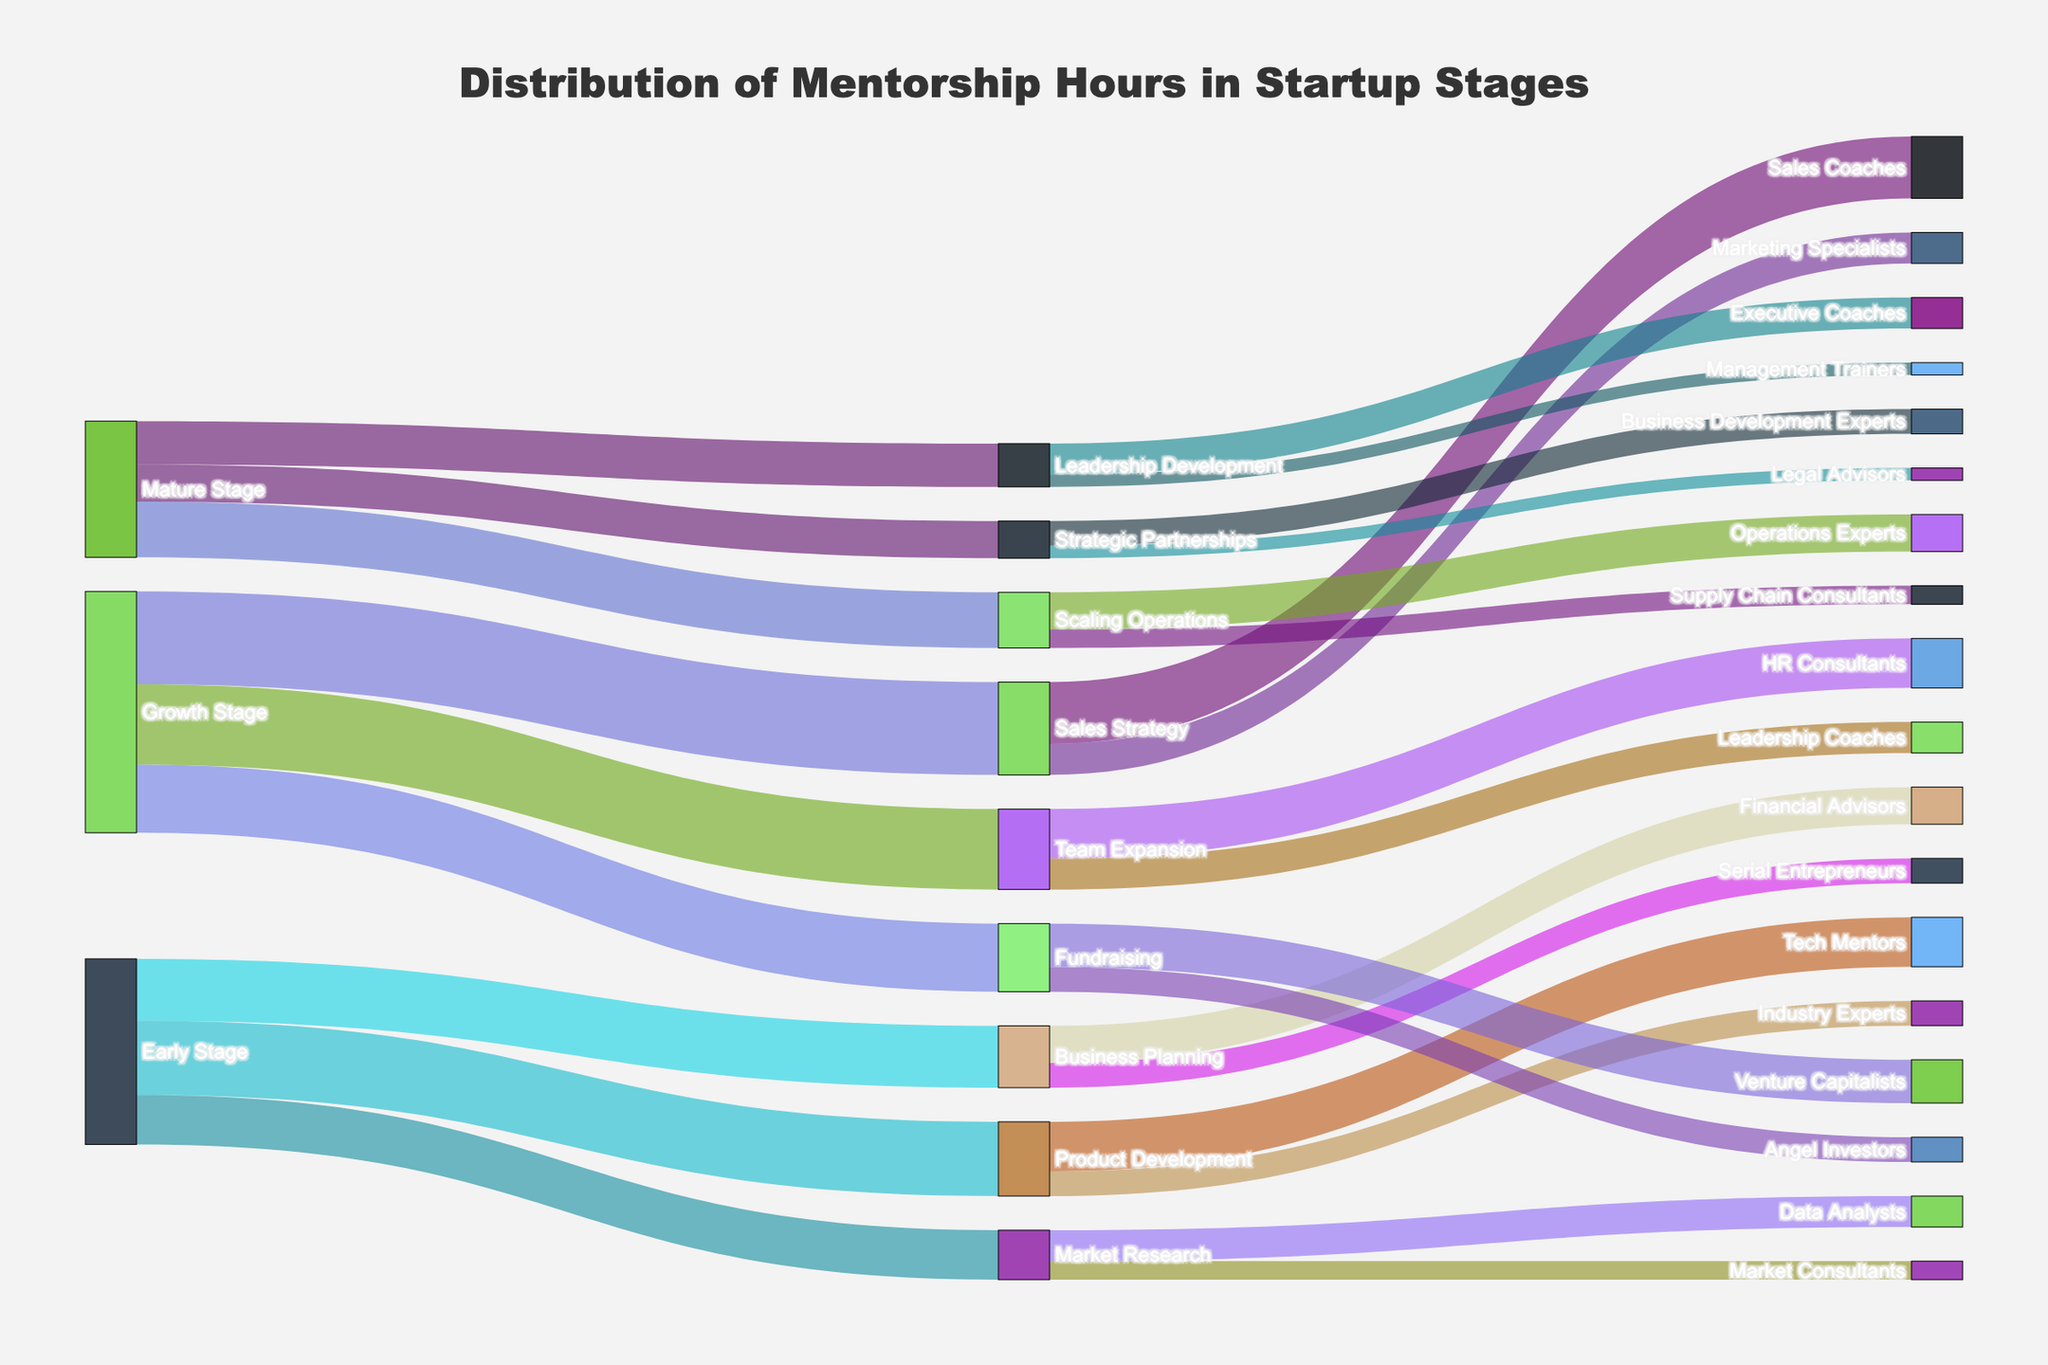What is the title of the Sankey Diagram? The title is prominently displayed at the top center of the diagram. It states the theme or main focus of the visual representation.
Answer: Distribution of Mentorship Hours in Startup Stages How many startup stages are depicted in the figure? Look for the primary categories on the left-hand side of the diagram. They represent the initial stages before branching out. Count these categories.
Answer: 3 Which stage received the most mentorship hours in the 'Team Expansion' target? Identify the 'Team Expansion' target in the diagram, trace back to the source stage, and identify the corresponding mentorship hours.
Answer: Growth Stage (130 hours) What is the sum of mentorship hours received by 'Product Development'? Identify all the mentorship hours linked to the 'Product Development' target and sum them up: Tech Mentors (80) + Industry Experts (40). The total is 80 + 40.
Answer: 120 hours Which mentorship provider offers guidance for both 'Fundraising' and 'Scaling Operations'? Look at the 'Fundraising' and 'Scaling Operations' targets and trace back to see if any provider links to both targets.
Answer: None Compare the mentorship hours between 'Early Stage' and 'Mature Stage' for 'Business Planning' and 'Strategic Partnerships'. Which stage has more total hours? Calculate the sum for each stage: Early Stage has Business Planning (100) and Mature Stage has Strategic Partnerships (60). Therefore, Early Stage has 100 and Mature Stage has 60.
Answer: Early Stage What is the difference in mentorship hours between 'Serial Entrepreneurs' and 'Data Analysts'? Find the values for 'Serial Entrepreneurs' (40) under 'Business Planning' and 'Data Analysts' (50) under 'Market Research'. Subtract the smaller value from the larger value: 50 - 40.
Answer: 10 hours How many different mentorship providers are shown in the figure? Look at the rightmost side of the diagram where the mentorship providers are listed, and count each unique provider.
Answer: 14 